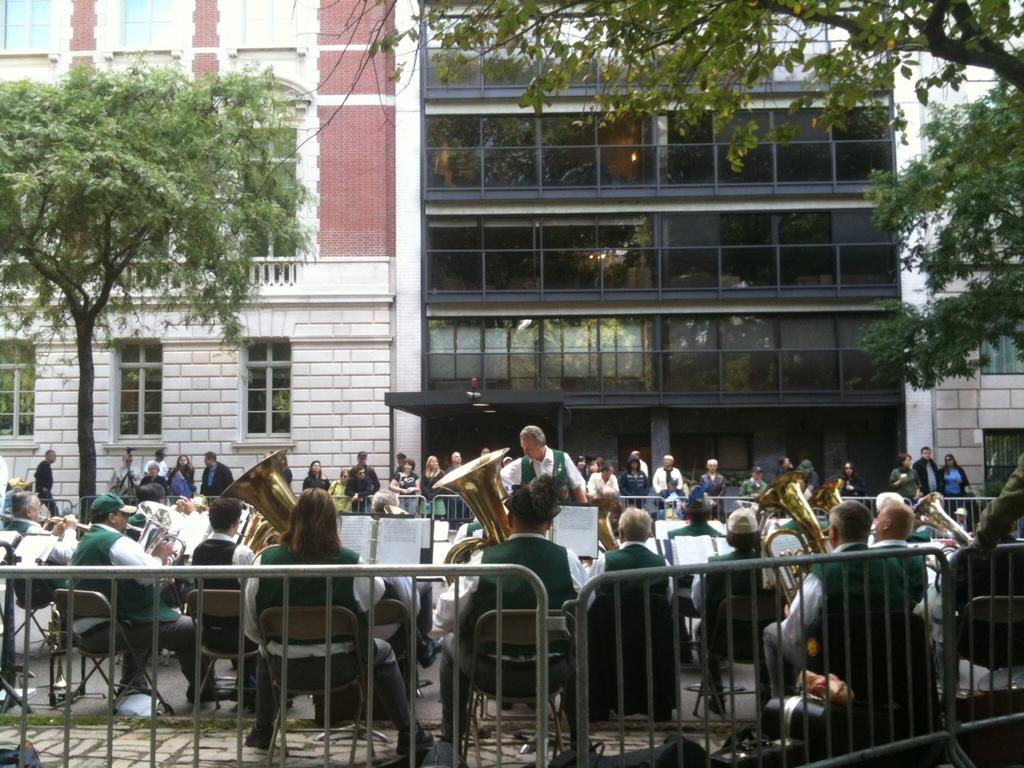What are the people in the image doing? The people in the image are playing musical instruments. What can be seen in the background of the image? There is a building and trees in the background of the image. How much water is being used by the man in the image? There is no man or water present in the image; it features a group of people playing musical instruments with a background of a building and trees. 